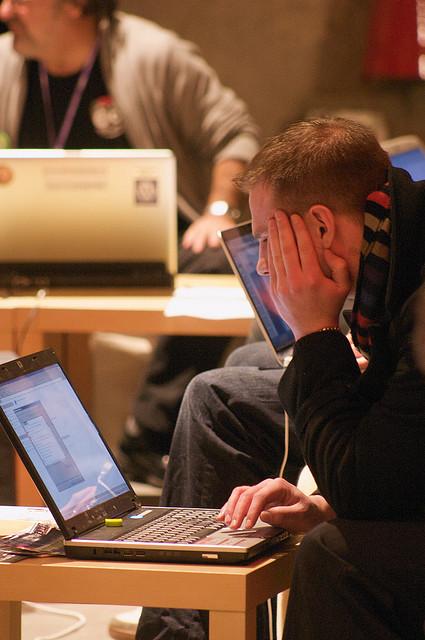How many laptops can be seen in this picture?
Answer briefly. 4. What brand of laptop are they using?
Short answer required. Hp. Is this person using a Mac computer?
Give a very brief answer. No. Could this person be a student?
Give a very brief answer. Yes. 